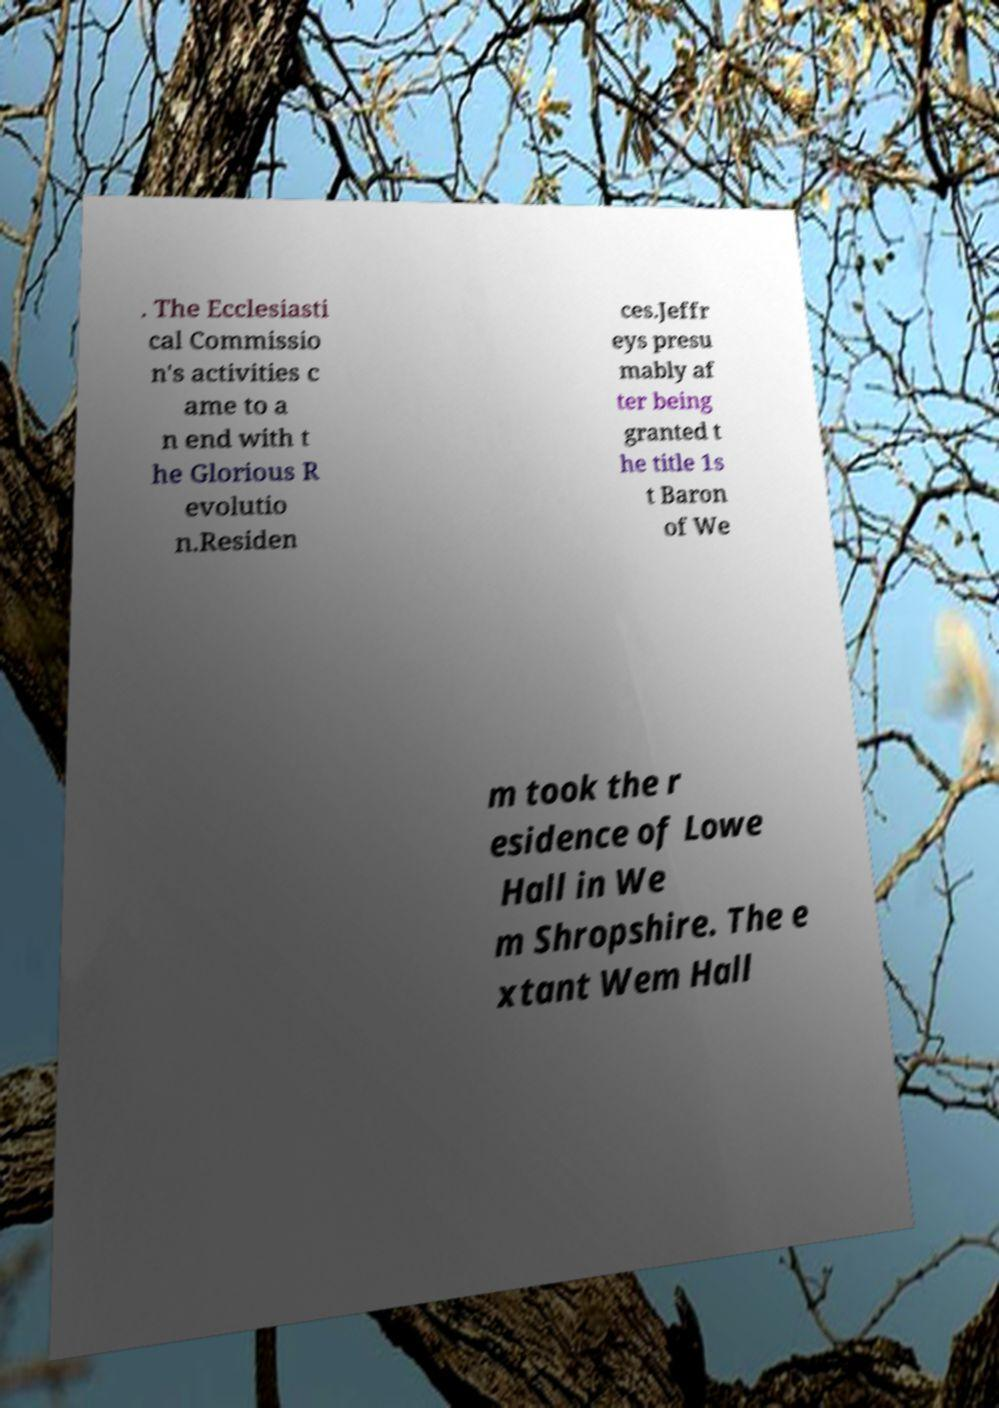Could you assist in decoding the text presented in this image and type it out clearly? . The Ecclesiasti cal Commissio n's activities c ame to a n end with t he Glorious R evolutio n.Residen ces.Jeffr eys presu mably af ter being granted t he title 1s t Baron of We m took the r esidence of Lowe Hall in We m Shropshire. The e xtant Wem Hall 